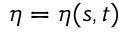<formula> <loc_0><loc_0><loc_500><loc_500>\eta = \eta ( s , t )</formula> 